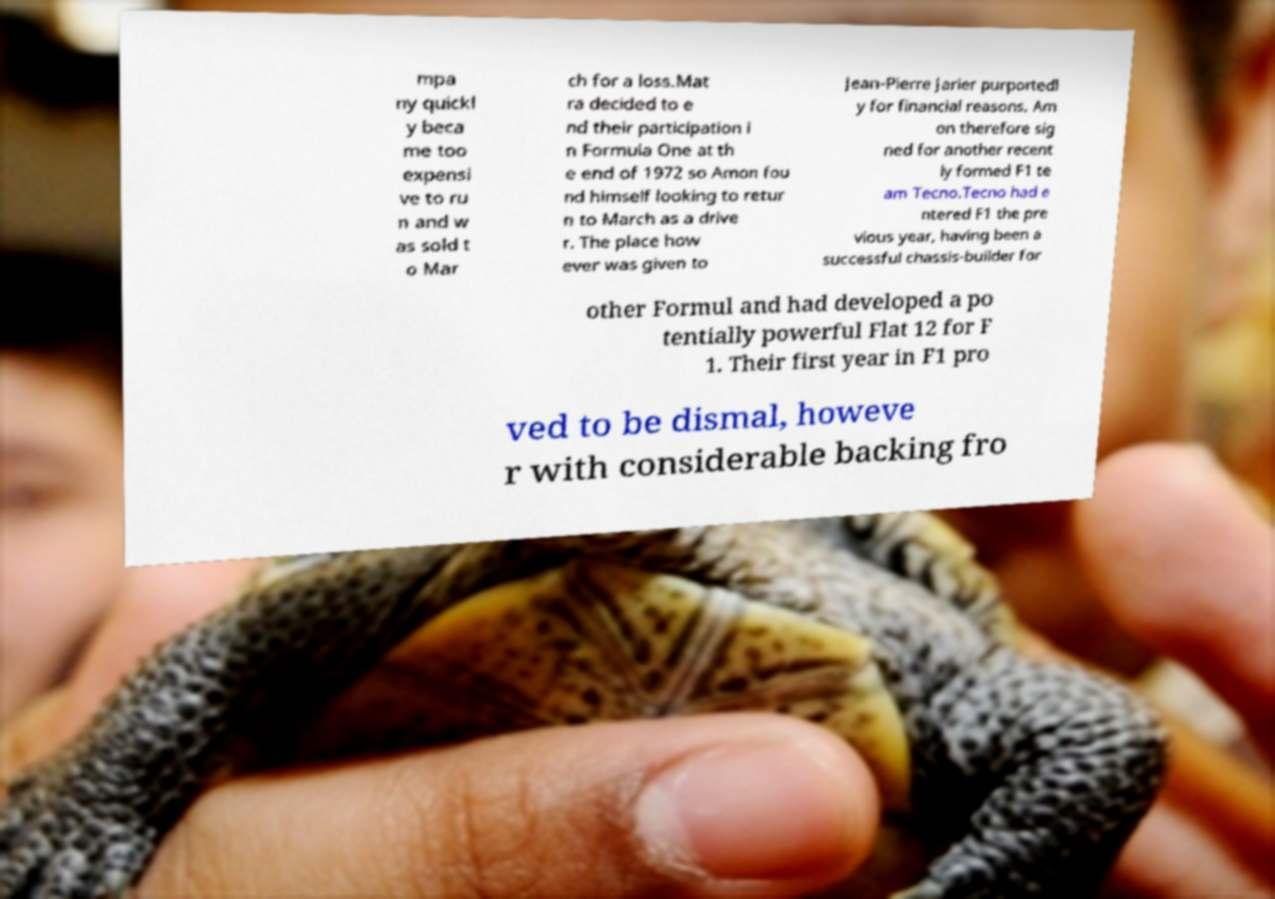Could you assist in decoding the text presented in this image and type it out clearly? mpa ny quickl y beca me too expensi ve to ru n and w as sold t o Mar ch for a loss.Mat ra decided to e nd their participation i n Formula One at th e end of 1972 so Amon fou nd himself looking to retur n to March as a drive r. The place how ever was given to Jean-Pierre Jarier purportedl y for financial reasons. Am on therefore sig ned for another recent ly formed F1 te am Tecno.Tecno had e ntered F1 the pre vious year, having been a successful chassis-builder for other Formul and had developed a po tentially powerful Flat 12 for F 1. Their first year in F1 pro ved to be dismal, howeve r with considerable backing fro 